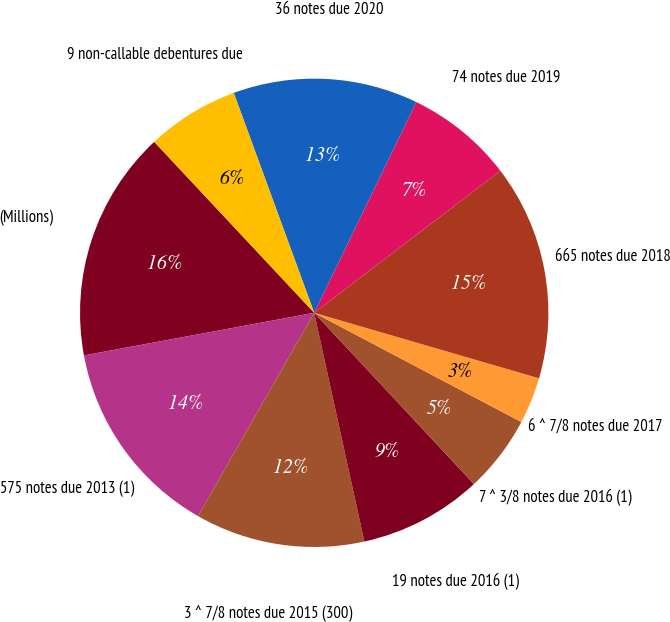Convert chart. <chart><loc_0><loc_0><loc_500><loc_500><pie_chart><fcel>(Millions)<fcel>575 notes due 2013 (1)<fcel>3 ^ 7/8 notes due 2015 (300)<fcel>19 notes due 2016 (1)<fcel>7 ^ 3/8 notes due 2016 (1)<fcel>6 ^ 7/8 notes due 2017<fcel>665 notes due 2018<fcel>74 notes due 2019<fcel>36 notes due 2020<fcel>9 non-callable debentures due<nl><fcel>15.94%<fcel>13.82%<fcel>11.7%<fcel>8.51%<fcel>5.33%<fcel>3.21%<fcel>14.88%<fcel>7.45%<fcel>12.76%<fcel>6.39%<nl></chart> 